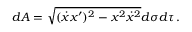<formula> <loc_0><loc_0><loc_500><loc_500>d A = \sqrt { ( \dot { x } x ^ { \prime } ) ^ { 2 } - x ^ { 2 } \dot { x } ^ { 2 } } d \sigma d \tau \, .</formula> 